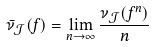Convert formula to latex. <formula><loc_0><loc_0><loc_500><loc_500>\bar { \nu } _ { \mathcal { J } } ( f ) = \lim _ { n \to \infty } \frac { \nu _ { \mathcal { J } } ( f ^ { n } ) } { n }</formula> 